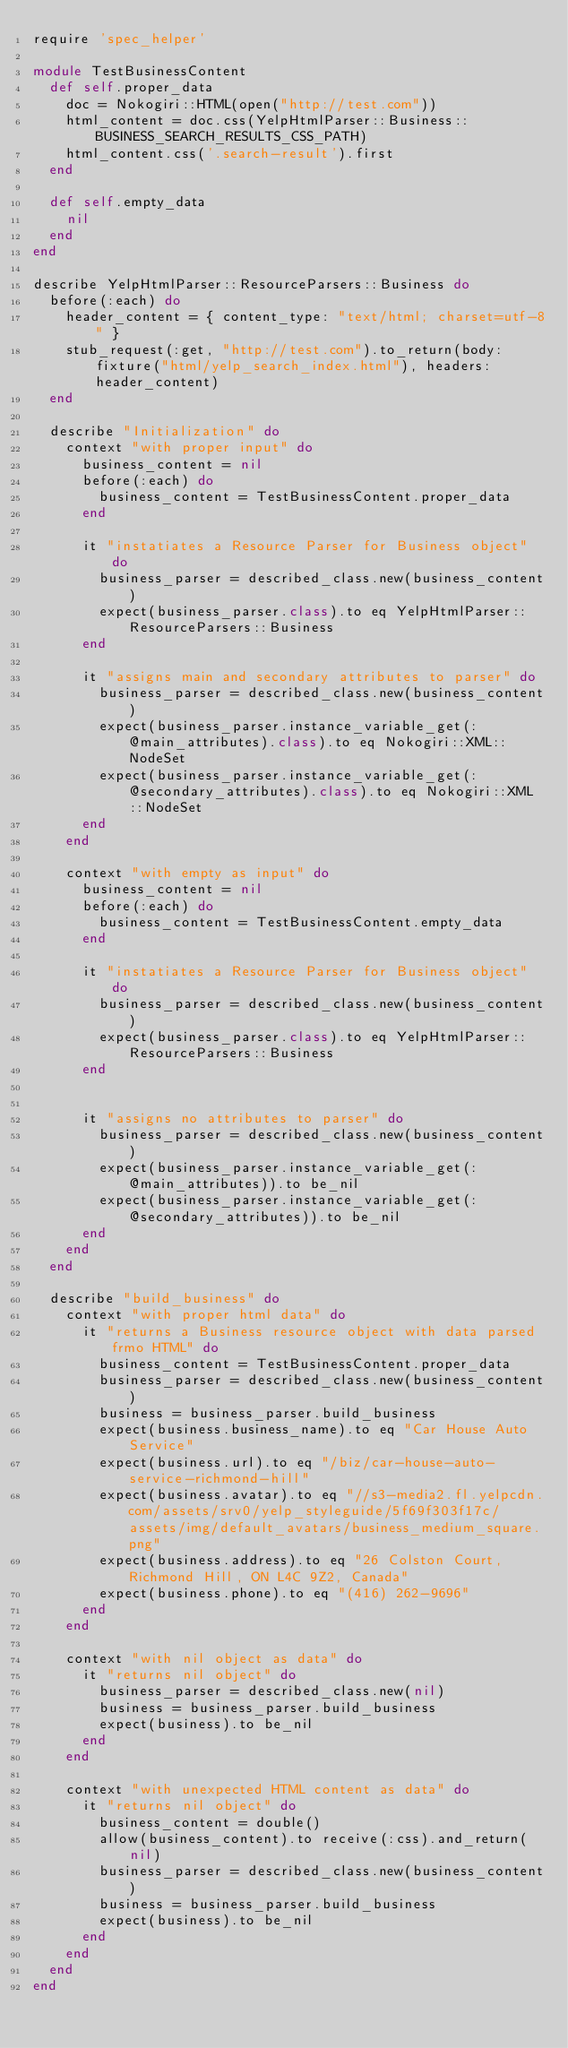Convert code to text. <code><loc_0><loc_0><loc_500><loc_500><_Ruby_>require 'spec_helper'

module TestBusinessContent
  def self.proper_data
    doc = Nokogiri::HTML(open("http://test.com"))
    html_content = doc.css(YelpHtmlParser::Business::BUSINESS_SEARCH_RESULTS_CSS_PATH)
    html_content.css('.search-result').first
  end

  def self.empty_data
    nil
  end
end

describe YelpHtmlParser::ResourceParsers::Business do
  before(:each) do
    header_content = { content_type: "text/html; charset=utf-8" }
    stub_request(:get, "http://test.com").to_return(body: fixture("html/yelp_search_index.html"), headers: header_content)
  end

  describe "Initialization" do
    context "with proper input" do
      business_content = nil
      before(:each) do
        business_content = TestBusinessContent.proper_data
      end

      it "instatiates a Resource Parser for Business object" do
        business_parser = described_class.new(business_content)
        expect(business_parser.class).to eq YelpHtmlParser::ResourceParsers::Business
      end

      it "assigns main and secondary attributes to parser" do
        business_parser = described_class.new(business_content)
        expect(business_parser.instance_variable_get(:@main_attributes).class).to eq Nokogiri::XML::NodeSet
        expect(business_parser.instance_variable_get(:@secondary_attributes).class).to eq Nokogiri::XML::NodeSet
      end
    end

    context "with empty as input" do
      business_content = nil
      before(:each) do
        business_content = TestBusinessContent.empty_data
      end

      it "instatiates a Resource Parser for Business object" do
        business_parser = described_class.new(business_content)
        expect(business_parser.class).to eq YelpHtmlParser::ResourceParsers::Business
      end


      it "assigns no attributes to parser" do
        business_parser = described_class.new(business_content)
        expect(business_parser.instance_variable_get(:@main_attributes)).to be_nil
        expect(business_parser.instance_variable_get(:@secondary_attributes)).to be_nil
      end
    end
  end

  describe "build_business" do
    context "with proper html data" do
      it "returns a Business resource object with data parsed frmo HTML" do
        business_content = TestBusinessContent.proper_data
        business_parser = described_class.new(business_content)
        business = business_parser.build_business
        expect(business.business_name).to eq "Car House Auto Service"
        expect(business.url).to eq "/biz/car-house-auto-service-richmond-hill"
        expect(business.avatar).to eq "//s3-media2.fl.yelpcdn.com/assets/srv0/yelp_styleguide/5f69f303f17c/assets/img/default_avatars/business_medium_square.png"
        expect(business.address).to eq "26 Colston Court, Richmond Hill, ON L4C 9Z2, Canada"
        expect(business.phone).to eq "(416) 262-9696"
      end
    end

    context "with nil object as data" do
      it "returns nil object" do
        business_parser = described_class.new(nil)
        business = business_parser.build_business
        expect(business).to be_nil
      end
    end

    context "with unexpected HTML content as data" do
      it "returns nil object" do
        business_content = double()
        allow(business_content).to receive(:css).and_return(nil)
        business_parser = described_class.new(business_content)
        business = business_parser.build_business
        expect(business).to be_nil
      end
    end
  end
end
</code> 